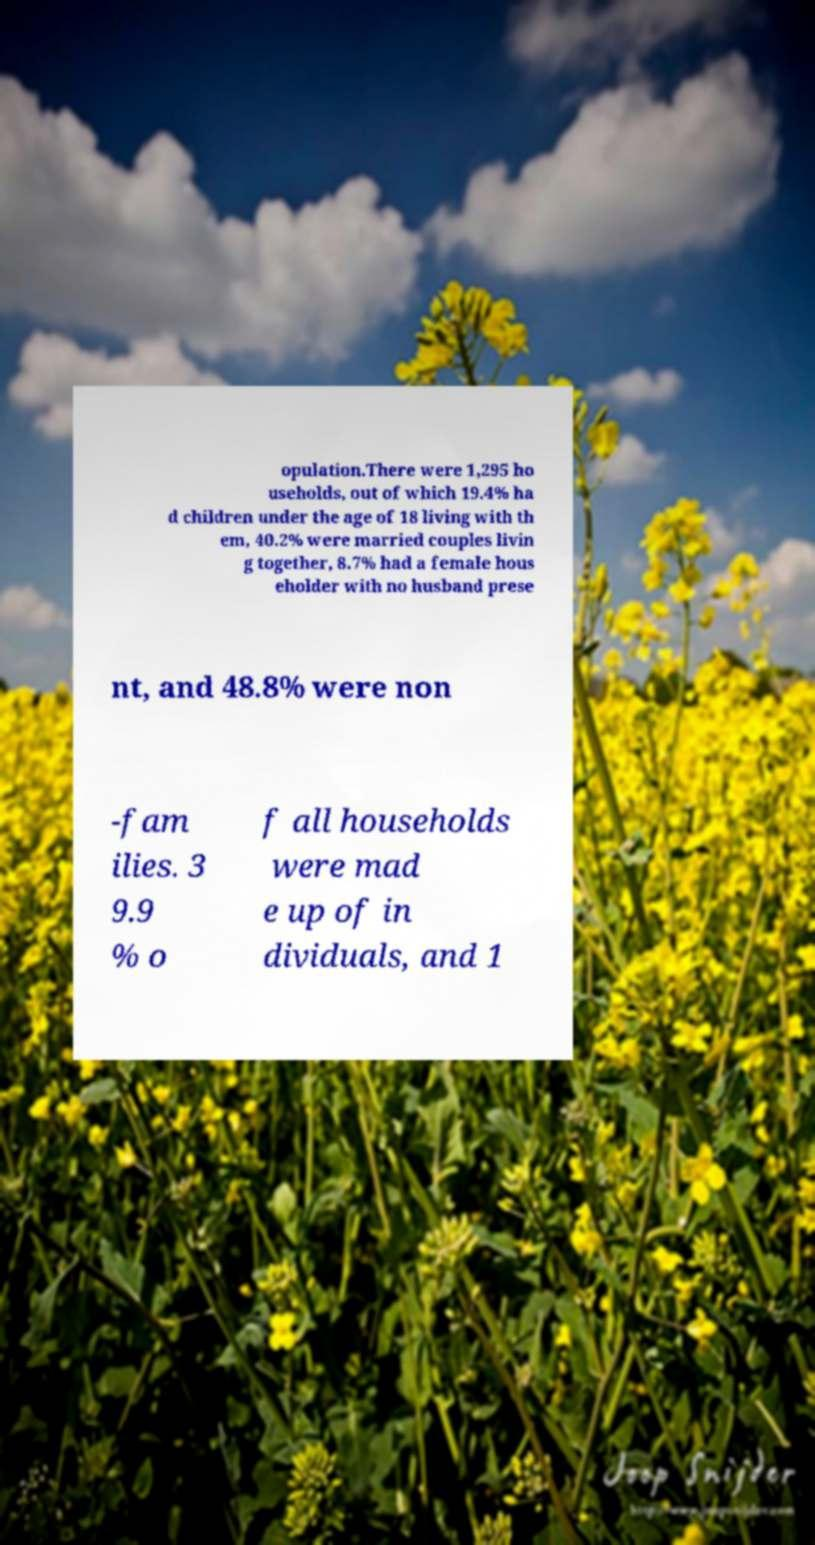There's text embedded in this image that I need extracted. Can you transcribe it verbatim? opulation.There were 1,295 ho useholds, out of which 19.4% ha d children under the age of 18 living with th em, 40.2% were married couples livin g together, 8.7% had a female hous eholder with no husband prese nt, and 48.8% were non -fam ilies. 3 9.9 % o f all households were mad e up of in dividuals, and 1 